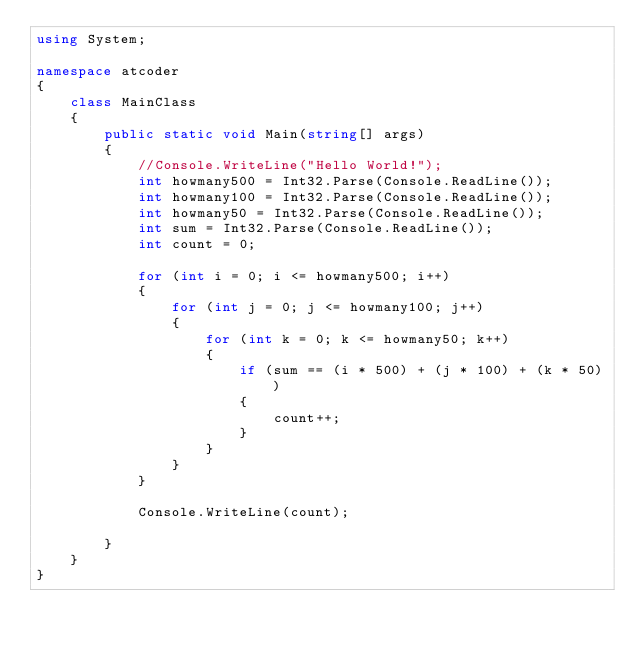<code> <loc_0><loc_0><loc_500><loc_500><_C#_>using System;

namespace atcoder
{
    class MainClass
    {
        public static void Main(string[] args)
        {
            //Console.WriteLine("Hello World!");
            int howmany500 = Int32.Parse(Console.ReadLine());
            int howmany100 = Int32.Parse(Console.ReadLine());
            int howmany50 = Int32.Parse(Console.ReadLine());
            int sum = Int32.Parse(Console.ReadLine());
            int count = 0;

            for (int i = 0; i <= howmany500; i++)
            {
                for (int j = 0; j <= howmany100; j++)
                {
                    for (int k = 0; k <= howmany50; k++)
                    {
                        if (sum == (i * 500) + (j * 100) + (k * 50))
                        {
                            count++;
                        }
                    }
                }
            }

            Console.WriteLine(count);

        }
    }
}</code> 